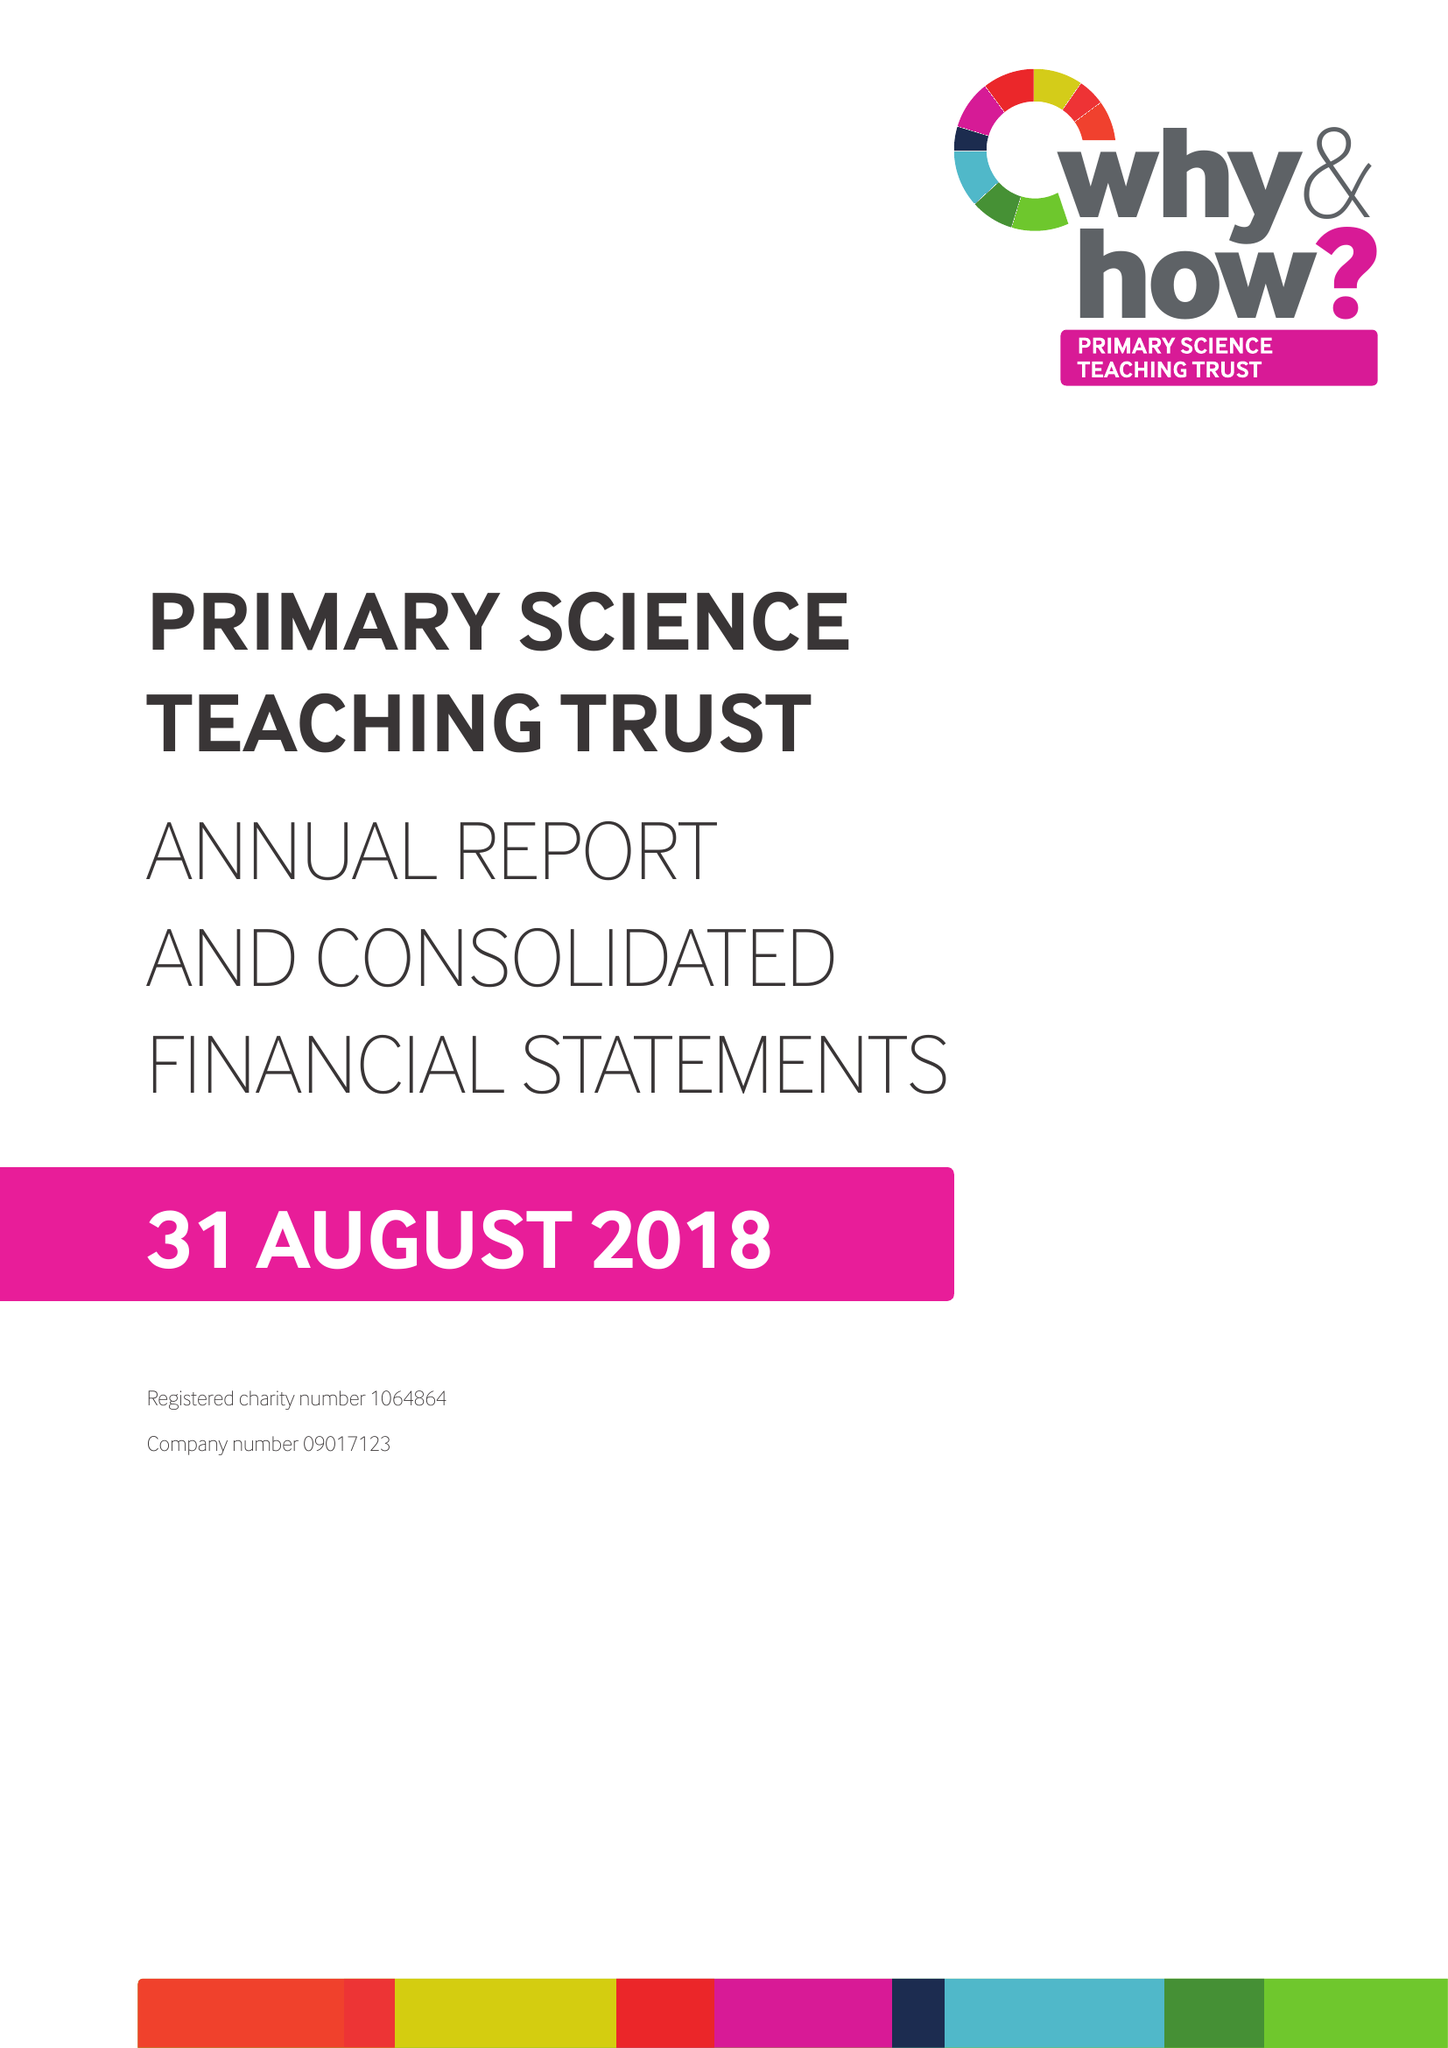What is the value for the address__post_town?
Answer the question using a single word or phrase. BRISTOL 